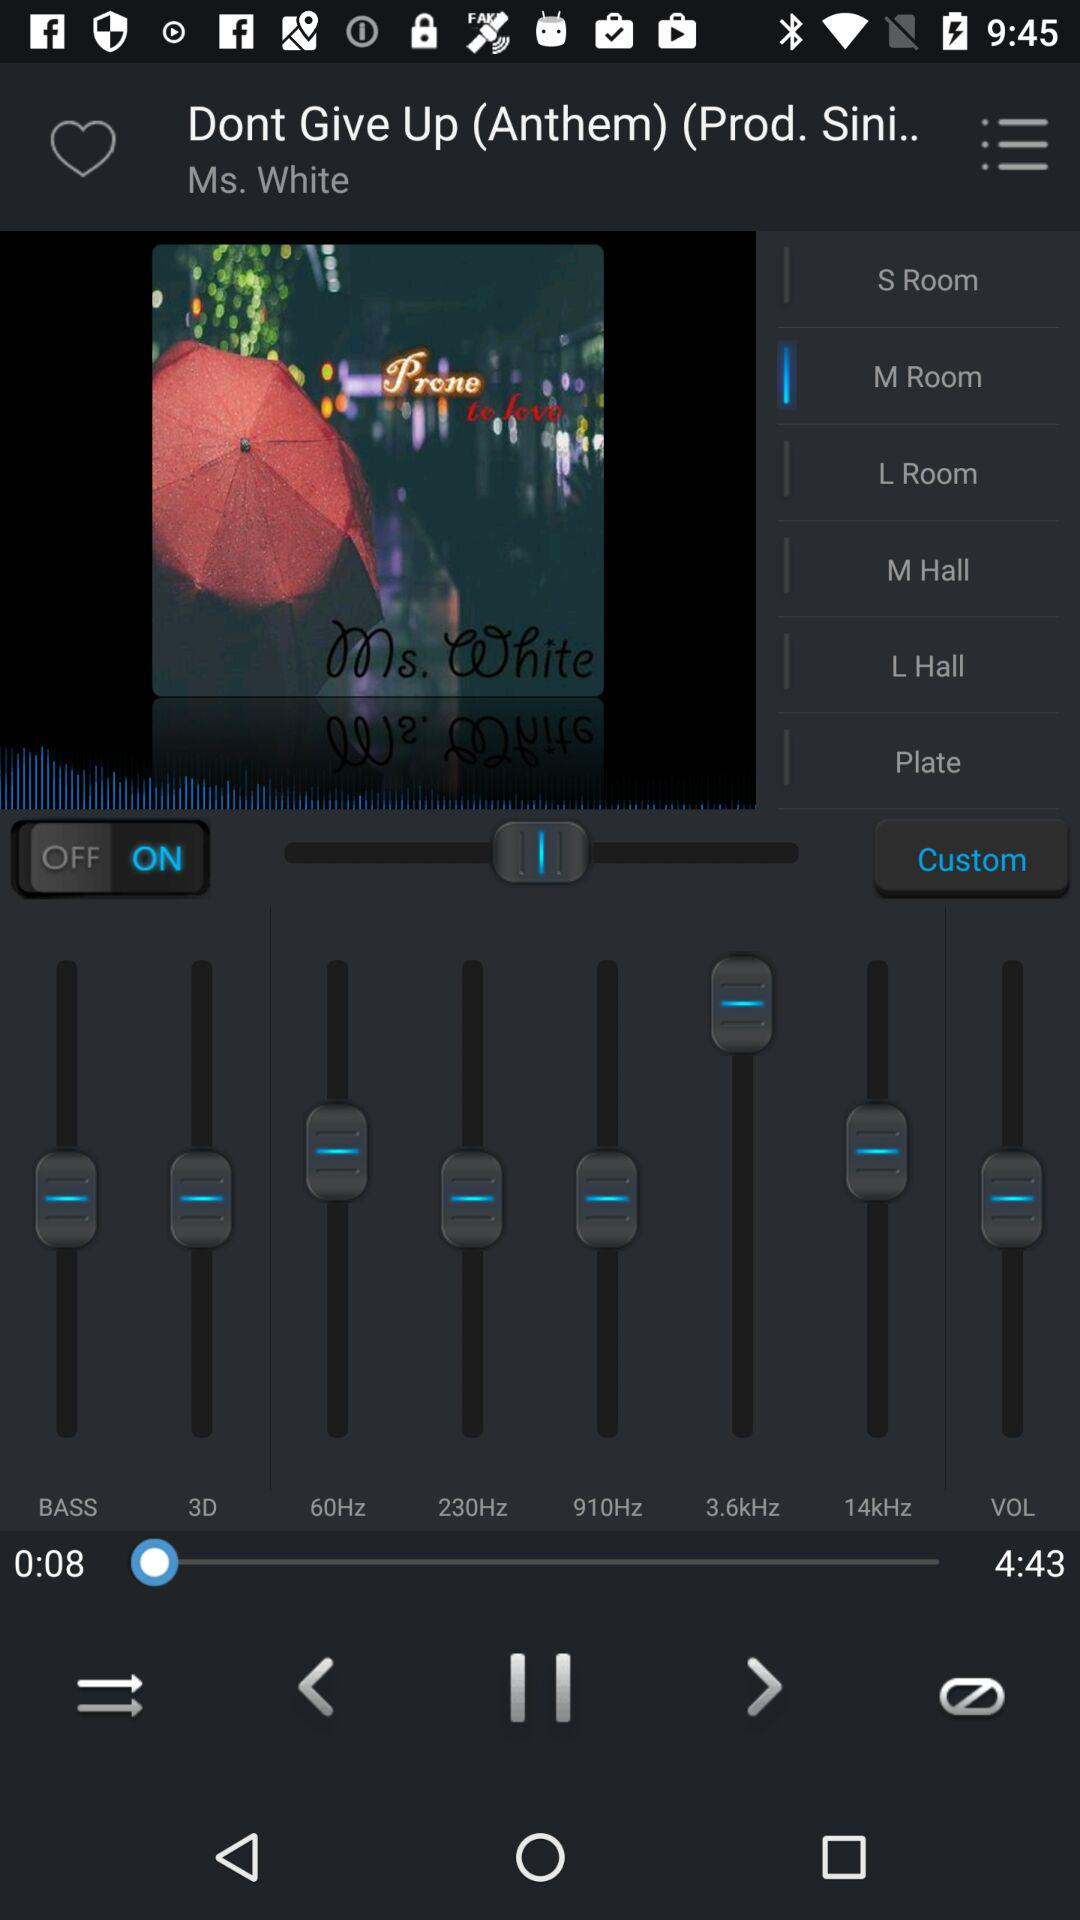What is the name of the song? The name of the song is "Dont Give Up". 